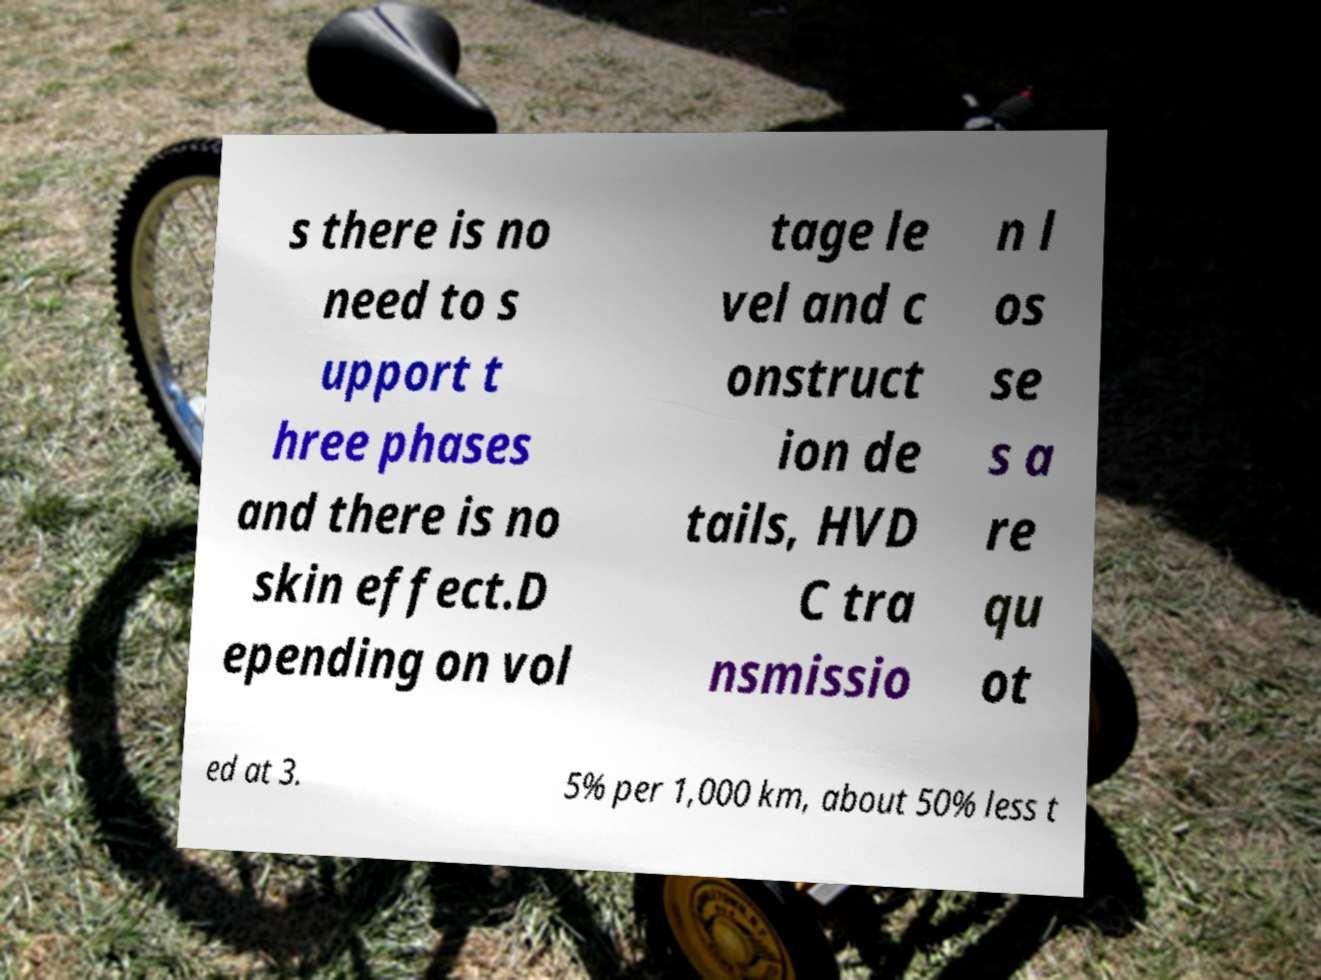Can you read and provide the text displayed in the image?This photo seems to have some interesting text. Can you extract and type it out for me? s there is no need to s upport t hree phases and there is no skin effect.D epending on vol tage le vel and c onstruct ion de tails, HVD C tra nsmissio n l os se s a re qu ot ed at 3. 5% per 1,000 km, about 50% less t 